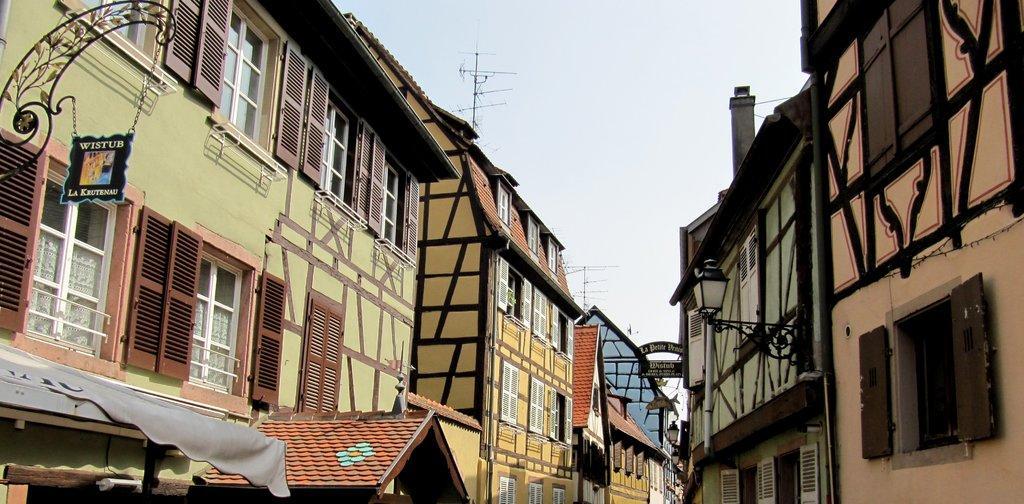Describe this image in one or two sentences. In this picture we can see many buildings. On the top left corner there is a sign board which is hanging from this ride. Here we can see windows. On the right there is a street light. On the top there is a tower or antenna. Here it's a sky. 